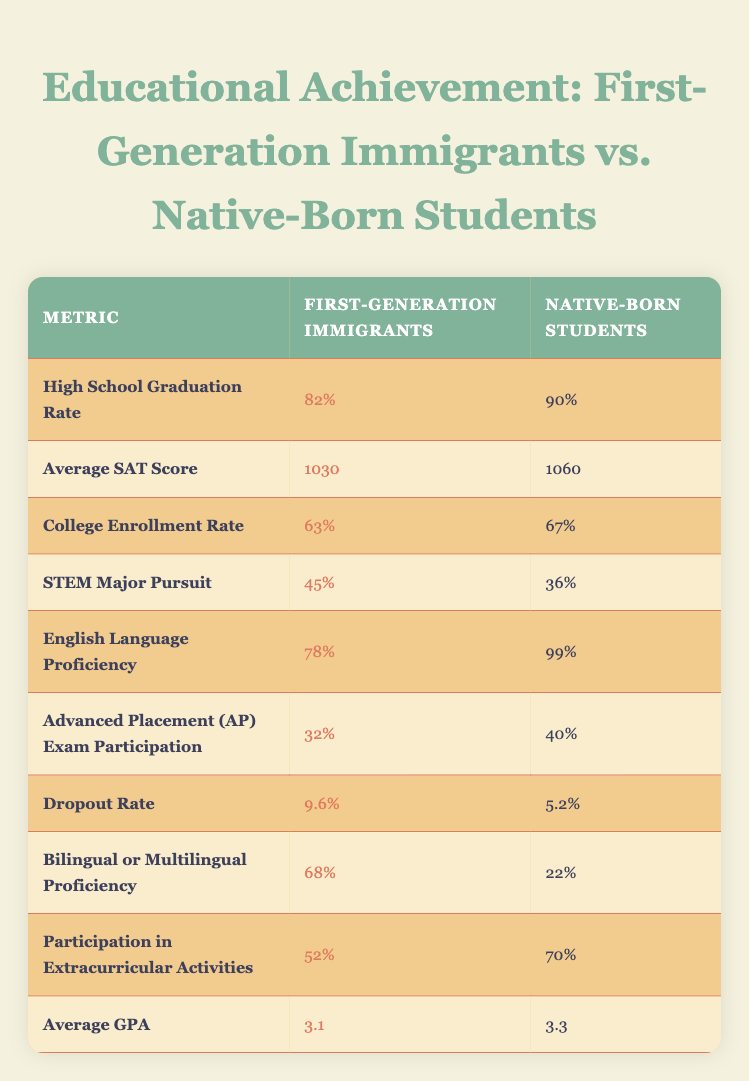What is the high school graduation rate for first-generation immigrants? The table lists the high school graduation rate for first-generation immigrants as 82%. This is taken directly from the first row of the table under the "First-Generation Immigrants" column.
Answer: 82% What percentage of native-born students pursue STEM majors? According to the table, the percentage of native-born students pursuing STEM majors is 36%. This information is found in the row labeled "STEM Major Pursuit" under the "Native-Born Students" column.
Answer: 36% Is the average GPA of first-generation immigrants higher than that of native-born students? The average GPA for first-generation immigrants is 3.1, while for native-born students it is 3.3. Since 3.1 is less than 3.3, this statement is false.
Answer: No What is the difference in dropout rates between first-generation immigrants and native-born students? The dropout rate for first-generation immigrants is 9.6%, and for native-born students, it is 5.2%. To find the difference, subtract 5.2 from 9.6: (9.6 - 5.2) = 4.4%. This means first-generation immigrants have a higher dropout rate by this amount.
Answer: 4.4% What percentage of first-generation immigrants are proficient in English? From the table, it is indicated that 78% of first-generation immigrants are proficient in English. This is stated in the row corresponding to "English Language Proficiency."
Answer: 78% Are first-generation immigrants more likely to participate in extracurricular activities than native-born students? The table states that 52% of first-generation immigrants participate in extracurricular activities, while 70% of native-born students do. Since 52% is less than 70%, this statement is false.
Answer: No What is the average SAT score difference between first-generation immigrants and native-born students? The average SAT score for first-generation immigrants is 1030, and for native-born students, it is 1060. The difference is calculated by subtracting the immigrant score from the native score: (1060 - 1030) = 30. Thus, there is a 30-point difference favoring native-born students.
Answer: 30 How many more first-generation immigrants are bilingual or multilingual compared to native-born students? The table shows that 68% of first-generation immigrants are bilingual or multilingual compared to 22% of native-born students. To find the difference, subtract the percentage of native-born students from first-generation immigrants: (68 - 22) = 46%. Therefore, 46% more first-generation immigrants are proficient in more than one language.
Answer: 46% 